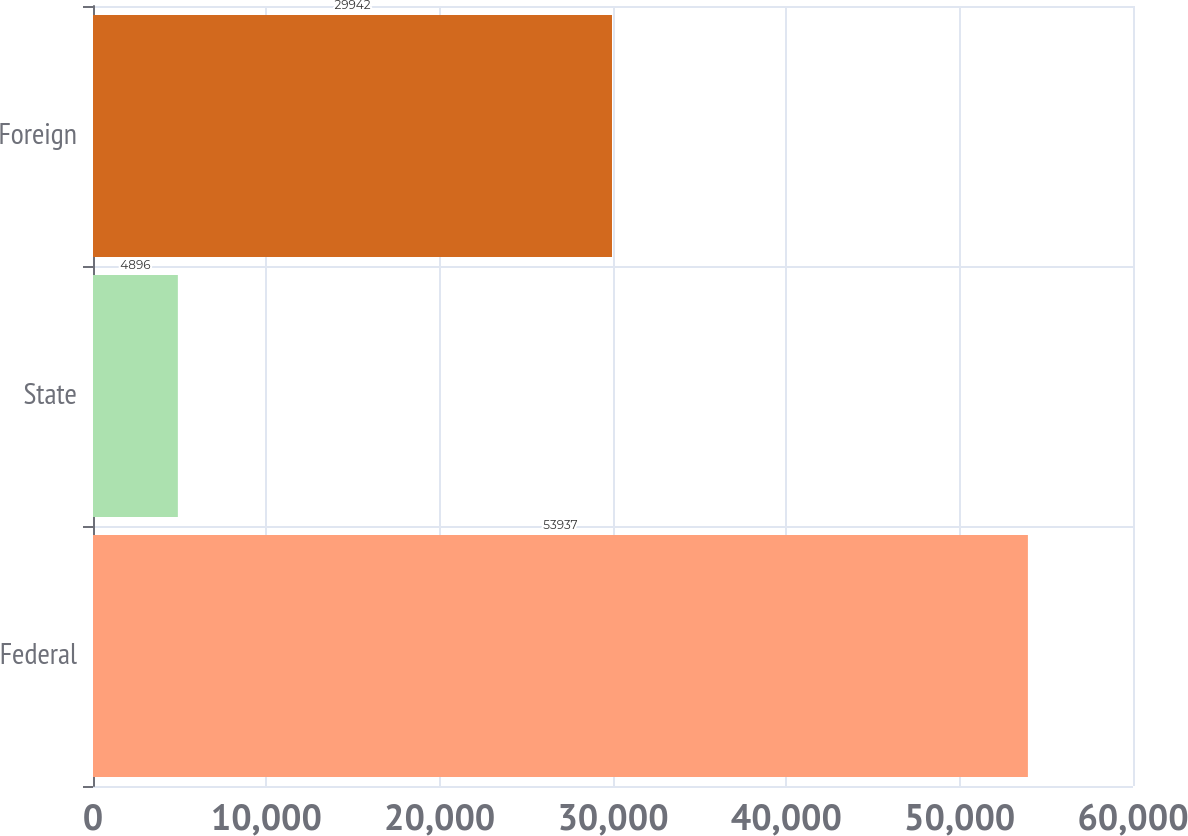Convert chart to OTSL. <chart><loc_0><loc_0><loc_500><loc_500><bar_chart><fcel>Federal<fcel>State<fcel>Foreign<nl><fcel>53937<fcel>4896<fcel>29942<nl></chart> 